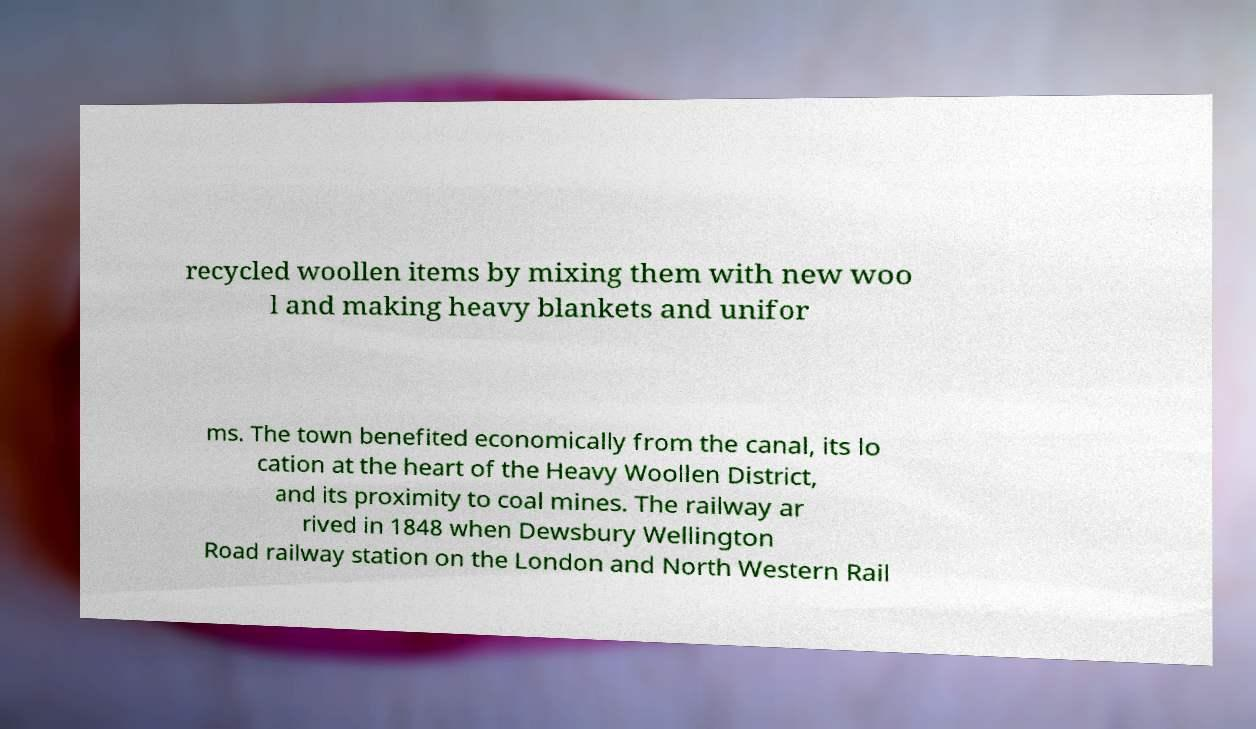Could you extract and type out the text from this image? recycled woollen items by mixing them with new woo l and making heavy blankets and unifor ms. The town benefited economically from the canal, its lo cation at the heart of the Heavy Woollen District, and its proximity to coal mines. The railway ar rived in 1848 when Dewsbury Wellington Road railway station on the London and North Western Rail 